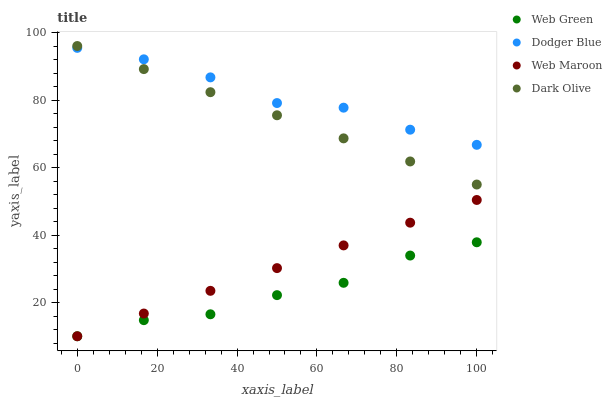Does Web Green have the minimum area under the curve?
Answer yes or no. Yes. Does Dodger Blue have the maximum area under the curve?
Answer yes or no. Yes. Does Dark Olive have the minimum area under the curve?
Answer yes or no. No. Does Dark Olive have the maximum area under the curve?
Answer yes or no. No. Is Web Maroon the smoothest?
Answer yes or no. Yes. Is Dodger Blue the roughest?
Answer yes or no. Yes. Is Dark Olive the smoothest?
Answer yes or no. No. Is Dark Olive the roughest?
Answer yes or no. No. Does Web Maroon have the lowest value?
Answer yes or no. Yes. Does Dark Olive have the lowest value?
Answer yes or no. No. Does Dark Olive have the highest value?
Answer yes or no. Yes. Does Dodger Blue have the highest value?
Answer yes or no. No. Is Web Maroon less than Dodger Blue?
Answer yes or no. Yes. Is Dark Olive greater than Web Green?
Answer yes or no. Yes. Does Web Maroon intersect Web Green?
Answer yes or no. Yes. Is Web Maroon less than Web Green?
Answer yes or no. No. Is Web Maroon greater than Web Green?
Answer yes or no. No. Does Web Maroon intersect Dodger Blue?
Answer yes or no. No. 